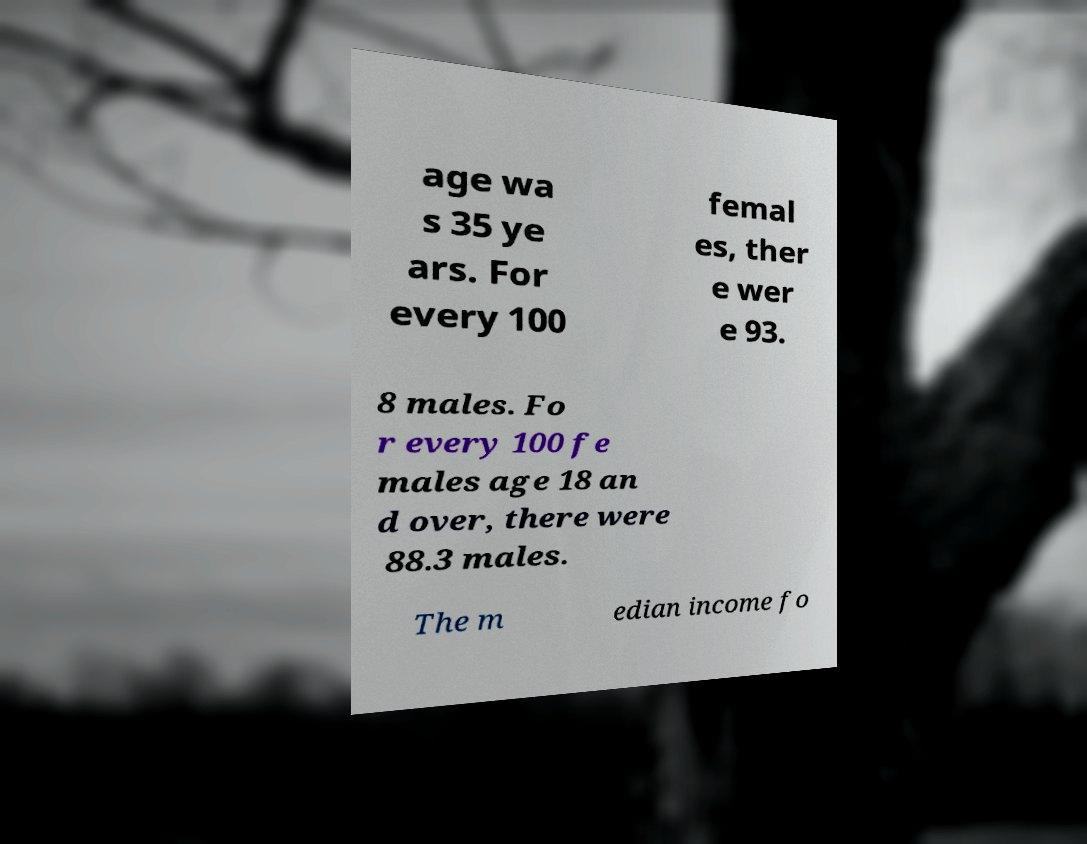For documentation purposes, I need the text within this image transcribed. Could you provide that? age wa s 35 ye ars. For every 100 femal es, ther e wer e 93. 8 males. Fo r every 100 fe males age 18 an d over, there were 88.3 males. The m edian income fo 